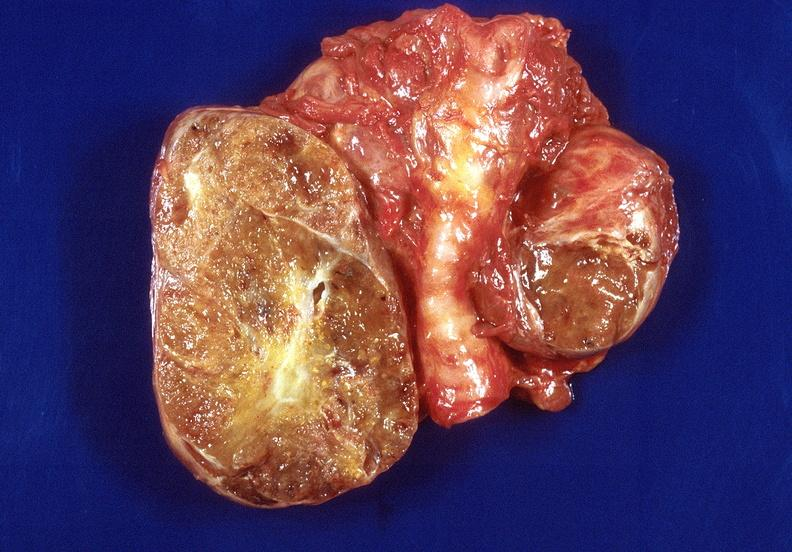s lymphangiomatosis present?
Answer the question using a single word or phrase. No 